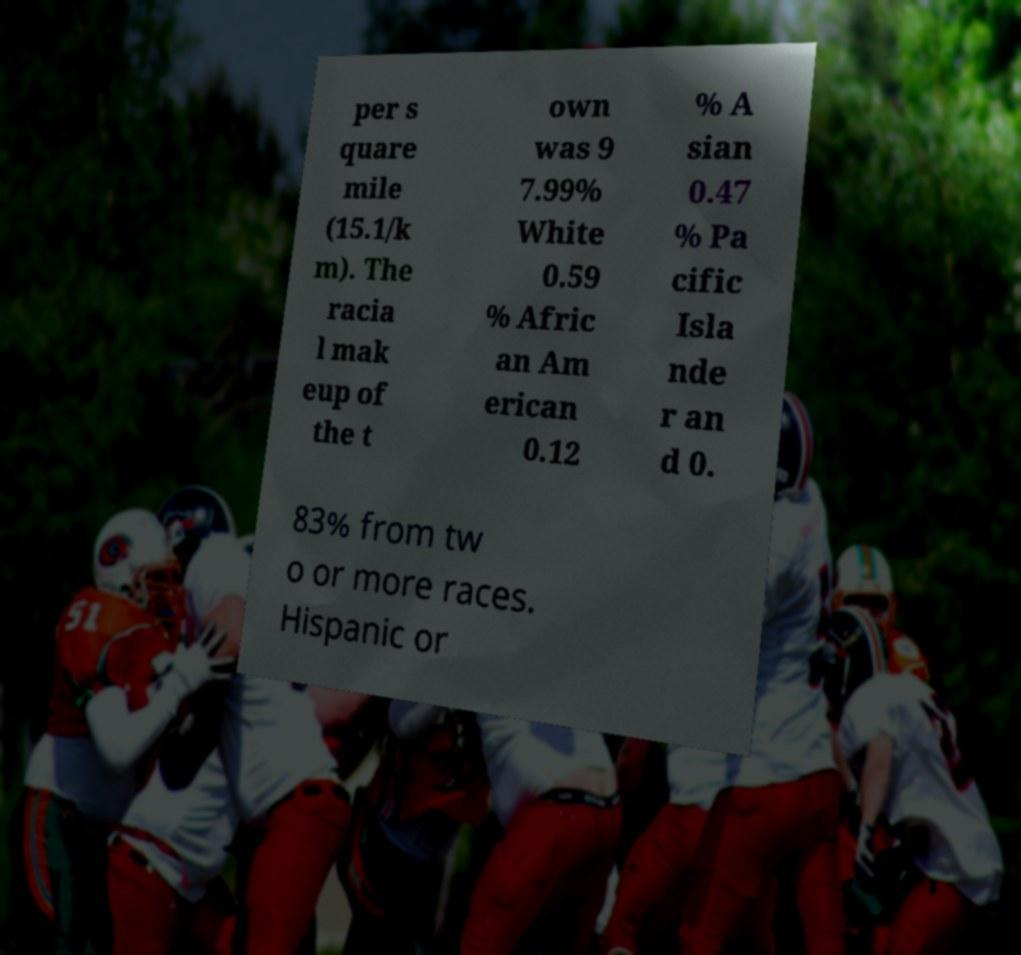Can you read and provide the text displayed in the image?This photo seems to have some interesting text. Can you extract and type it out for me? per s quare mile (15.1/k m). The racia l mak eup of the t own was 9 7.99% White 0.59 % Afric an Am erican 0.12 % A sian 0.47 % Pa cific Isla nde r an d 0. 83% from tw o or more races. Hispanic or 